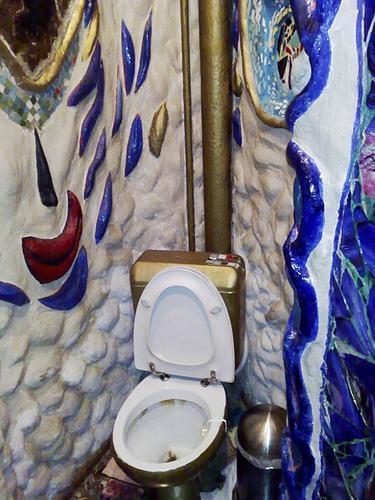How many people on the vase are holding a vase?
Give a very brief answer. 0. 